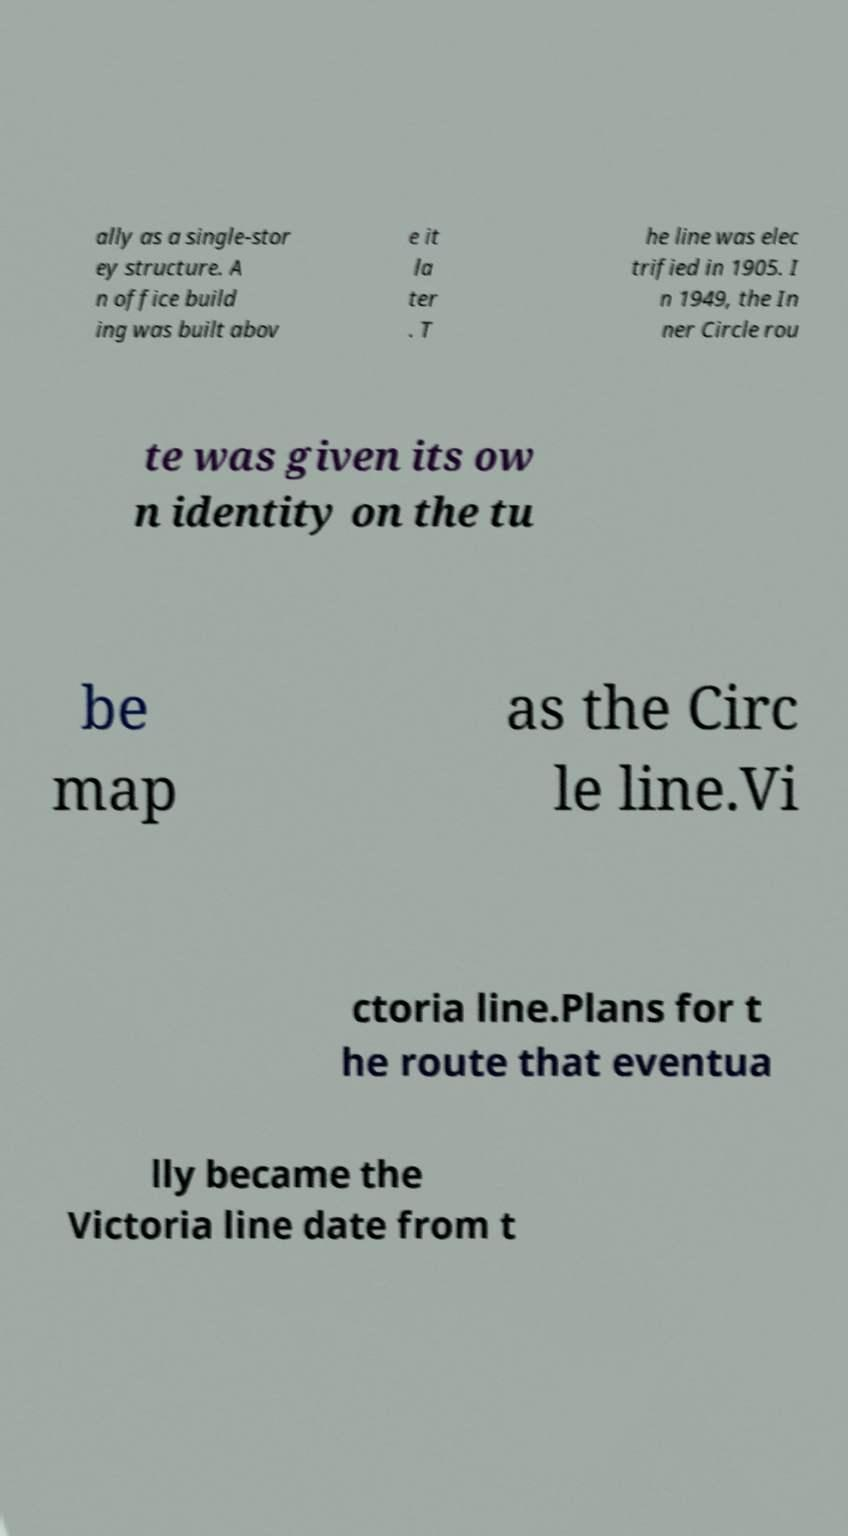What messages or text are displayed in this image? I need them in a readable, typed format. ally as a single-stor ey structure. A n office build ing was built abov e it la ter . T he line was elec trified in 1905. I n 1949, the In ner Circle rou te was given its ow n identity on the tu be map as the Circ le line.Vi ctoria line.Plans for t he route that eventua lly became the Victoria line date from t 